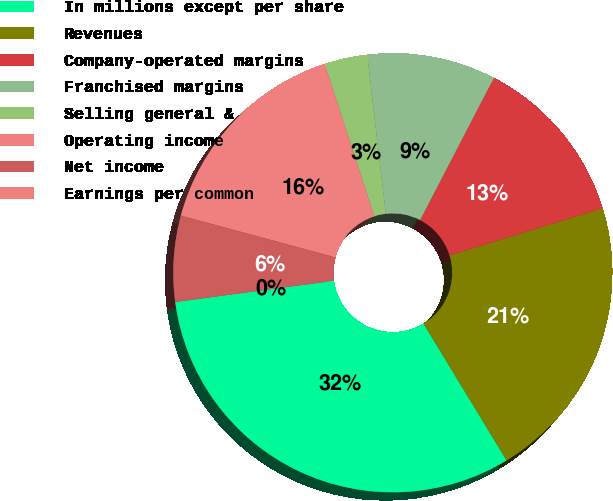<chart> <loc_0><loc_0><loc_500><loc_500><pie_chart><fcel>In millions except per share<fcel>Revenues<fcel>Company-operated margins<fcel>Franchised margins<fcel>Selling general &<fcel>Operating income<fcel>Net income<fcel>Earnings per common<nl><fcel>31.57%<fcel>21.06%<fcel>12.63%<fcel>9.47%<fcel>3.16%<fcel>15.79%<fcel>6.32%<fcel>0.0%<nl></chart> 